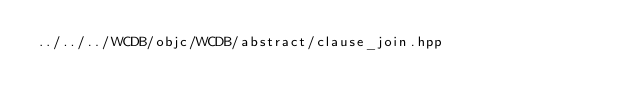Convert code to text. <code><loc_0><loc_0><loc_500><loc_500><_C++_>../../../WCDB/objc/WCDB/abstract/clause_join.hpp</code> 